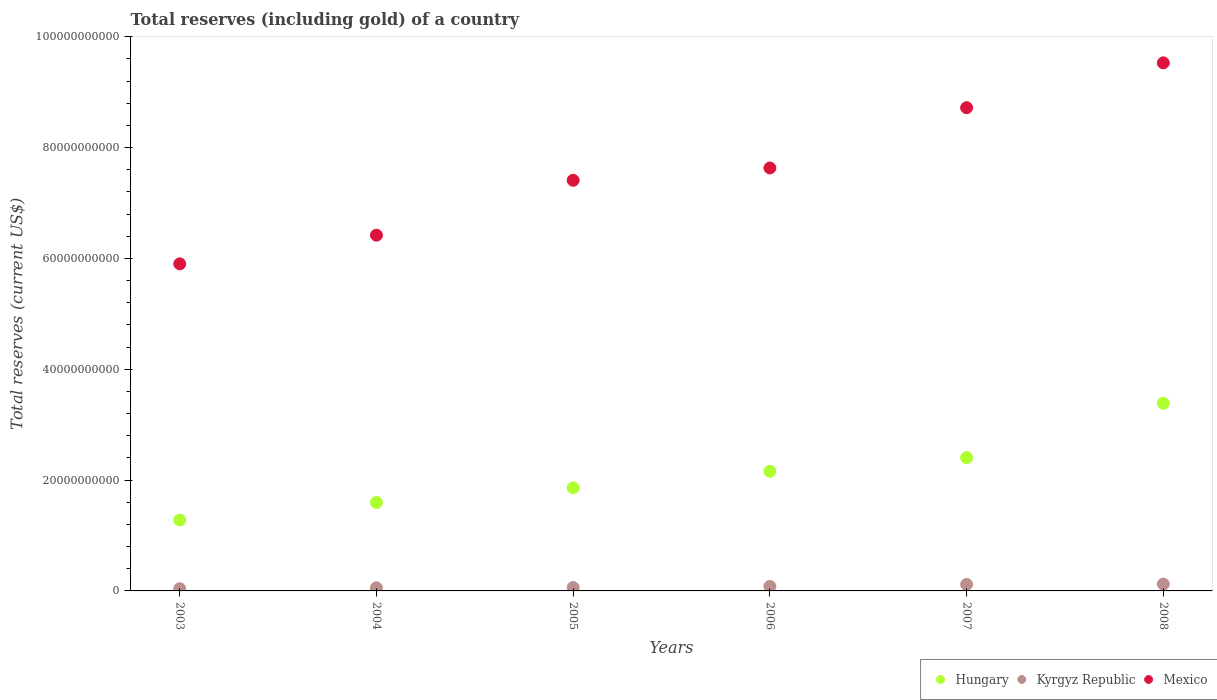What is the total reserves (including gold) in Mexico in 2007?
Provide a short and direct response. 8.72e+1. Across all years, what is the maximum total reserves (including gold) in Kyrgyz Republic?
Make the answer very short. 1.23e+09. Across all years, what is the minimum total reserves (including gold) in Kyrgyz Republic?
Offer a very short reply. 3.99e+08. What is the total total reserves (including gold) in Kyrgyz Republic in the graph?
Give a very brief answer. 4.79e+09. What is the difference between the total reserves (including gold) in Hungary in 2003 and that in 2004?
Ensure brevity in your answer.  -3.17e+09. What is the difference between the total reserves (including gold) in Mexico in 2004 and the total reserves (including gold) in Hungary in 2008?
Your answer should be very brief. 3.03e+1. What is the average total reserves (including gold) in Hungary per year?
Your answer should be compact. 2.11e+1. In the year 2005, what is the difference between the total reserves (including gold) in Kyrgyz Republic and total reserves (including gold) in Hungary?
Give a very brief answer. -1.80e+1. In how many years, is the total reserves (including gold) in Mexico greater than 48000000000 US$?
Your response must be concise. 6. What is the ratio of the total reserves (including gold) in Kyrgyz Republic in 2003 to that in 2006?
Give a very brief answer. 0.49. Is the difference between the total reserves (including gold) in Kyrgyz Republic in 2005 and 2008 greater than the difference between the total reserves (including gold) in Hungary in 2005 and 2008?
Your response must be concise. Yes. What is the difference between the highest and the second highest total reserves (including gold) in Mexico?
Your response must be concise. 8.09e+09. What is the difference between the highest and the lowest total reserves (including gold) in Kyrgyz Republic?
Your response must be concise. 8.26e+08. In how many years, is the total reserves (including gold) in Kyrgyz Republic greater than the average total reserves (including gold) in Kyrgyz Republic taken over all years?
Keep it short and to the point. 3. Is the total reserves (including gold) in Mexico strictly greater than the total reserves (including gold) in Kyrgyz Republic over the years?
Provide a short and direct response. Yes. What is the difference between two consecutive major ticks on the Y-axis?
Your answer should be very brief. 2.00e+1. Does the graph contain any zero values?
Your answer should be compact. No. Where does the legend appear in the graph?
Your answer should be very brief. Bottom right. What is the title of the graph?
Ensure brevity in your answer.  Total reserves (including gold) of a country. What is the label or title of the X-axis?
Your answer should be compact. Years. What is the label or title of the Y-axis?
Offer a terse response. Total reserves (current US$). What is the Total reserves (current US$) in Hungary in 2003?
Offer a terse response. 1.28e+1. What is the Total reserves (current US$) in Kyrgyz Republic in 2003?
Keep it short and to the point. 3.99e+08. What is the Total reserves (current US$) in Mexico in 2003?
Ensure brevity in your answer.  5.90e+1. What is the Total reserves (current US$) in Hungary in 2004?
Provide a succinct answer. 1.60e+1. What is the Total reserves (current US$) of Kyrgyz Republic in 2004?
Ensure brevity in your answer.  5.65e+08. What is the Total reserves (current US$) of Mexico in 2004?
Provide a succinct answer. 6.42e+1. What is the Total reserves (current US$) of Hungary in 2005?
Offer a terse response. 1.86e+1. What is the Total reserves (current US$) in Kyrgyz Republic in 2005?
Provide a succinct answer. 6.12e+08. What is the Total reserves (current US$) in Mexico in 2005?
Your answer should be very brief. 7.41e+1. What is the Total reserves (current US$) of Hungary in 2006?
Make the answer very short. 2.16e+1. What is the Total reserves (current US$) of Kyrgyz Republic in 2006?
Offer a very short reply. 8.17e+08. What is the Total reserves (current US$) of Mexico in 2006?
Give a very brief answer. 7.63e+1. What is the Total reserves (current US$) in Hungary in 2007?
Make the answer very short. 2.41e+1. What is the Total reserves (current US$) in Kyrgyz Republic in 2007?
Your answer should be very brief. 1.18e+09. What is the Total reserves (current US$) of Mexico in 2007?
Offer a very short reply. 8.72e+1. What is the Total reserves (current US$) in Hungary in 2008?
Provide a short and direct response. 3.39e+1. What is the Total reserves (current US$) in Kyrgyz Republic in 2008?
Your response must be concise. 1.23e+09. What is the Total reserves (current US$) of Mexico in 2008?
Ensure brevity in your answer.  9.53e+1. Across all years, what is the maximum Total reserves (current US$) in Hungary?
Your response must be concise. 3.39e+1. Across all years, what is the maximum Total reserves (current US$) of Kyrgyz Republic?
Your answer should be very brief. 1.23e+09. Across all years, what is the maximum Total reserves (current US$) of Mexico?
Offer a terse response. 9.53e+1. Across all years, what is the minimum Total reserves (current US$) in Hungary?
Give a very brief answer. 1.28e+1. Across all years, what is the minimum Total reserves (current US$) in Kyrgyz Republic?
Offer a terse response. 3.99e+08. Across all years, what is the minimum Total reserves (current US$) in Mexico?
Provide a succinct answer. 5.90e+1. What is the total Total reserves (current US$) of Hungary in the graph?
Make the answer very short. 1.27e+11. What is the total Total reserves (current US$) in Kyrgyz Republic in the graph?
Ensure brevity in your answer.  4.79e+09. What is the total Total reserves (current US$) of Mexico in the graph?
Make the answer very short. 4.56e+11. What is the difference between the Total reserves (current US$) of Hungary in 2003 and that in 2004?
Offer a very short reply. -3.17e+09. What is the difference between the Total reserves (current US$) of Kyrgyz Republic in 2003 and that in 2004?
Make the answer very short. -1.65e+08. What is the difference between the Total reserves (current US$) of Mexico in 2003 and that in 2004?
Offer a very short reply. -5.18e+09. What is the difference between the Total reserves (current US$) of Hungary in 2003 and that in 2005?
Your answer should be compact. -5.81e+09. What is the difference between the Total reserves (current US$) of Kyrgyz Republic in 2003 and that in 2005?
Give a very brief answer. -2.13e+08. What is the difference between the Total reserves (current US$) of Mexico in 2003 and that in 2005?
Your response must be concise. -1.51e+1. What is the difference between the Total reserves (current US$) in Hungary in 2003 and that in 2006?
Make the answer very short. -8.80e+09. What is the difference between the Total reserves (current US$) of Kyrgyz Republic in 2003 and that in 2006?
Offer a very short reply. -4.18e+08. What is the difference between the Total reserves (current US$) in Mexico in 2003 and that in 2006?
Make the answer very short. -1.73e+1. What is the difference between the Total reserves (current US$) of Hungary in 2003 and that in 2007?
Give a very brief answer. -1.13e+1. What is the difference between the Total reserves (current US$) of Kyrgyz Republic in 2003 and that in 2007?
Your response must be concise. -7.77e+08. What is the difference between the Total reserves (current US$) in Mexico in 2003 and that in 2007?
Your response must be concise. -2.82e+1. What is the difference between the Total reserves (current US$) of Hungary in 2003 and that in 2008?
Give a very brief answer. -2.11e+1. What is the difference between the Total reserves (current US$) in Kyrgyz Republic in 2003 and that in 2008?
Your answer should be very brief. -8.26e+08. What is the difference between the Total reserves (current US$) of Mexico in 2003 and that in 2008?
Your response must be concise. -3.63e+1. What is the difference between the Total reserves (current US$) in Hungary in 2004 and that in 2005?
Give a very brief answer. -2.64e+09. What is the difference between the Total reserves (current US$) in Kyrgyz Republic in 2004 and that in 2005?
Offer a very short reply. -4.78e+07. What is the difference between the Total reserves (current US$) in Mexico in 2004 and that in 2005?
Offer a very short reply. -9.91e+09. What is the difference between the Total reserves (current US$) in Hungary in 2004 and that in 2006?
Your answer should be very brief. -5.62e+09. What is the difference between the Total reserves (current US$) of Kyrgyz Republic in 2004 and that in 2006?
Keep it short and to the point. -2.53e+08. What is the difference between the Total reserves (current US$) of Mexico in 2004 and that in 2006?
Offer a very short reply. -1.21e+1. What is the difference between the Total reserves (current US$) of Hungary in 2004 and that in 2007?
Make the answer very short. -8.09e+09. What is the difference between the Total reserves (current US$) in Kyrgyz Republic in 2004 and that in 2007?
Offer a very short reply. -6.12e+08. What is the difference between the Total reserves (current US$) of Mexico in 2004 and that in 2007?
Ensure brevity in your answer.  -2.30e+1. What is the difference between the Total reserves (current US$) of Hungary in 2004 and that in 2008?
Offer a terse response. -1.79e+1. What is the difference between the Total reserves (current US$) in Kyrgyz Republic in 2004 and that in 2008?
Offer a very short reply. -6.61e+08. What is the difference between the Total reserves (current US$) in Mexico in 2004 and that in 2008?
Keep it short and to the point. -3.11e+1. What is the difference between the Total reserves (current US$) of Hungary in 2005 and that in 2006?
Offer a very short reply. -2.99e+09. What is the difference between the Total reserves (current US$) in Kyrgyz Republic in 2005 and that in 2006?
Provide a short and direct response. -2.05e+08. What is the difference between the Total reserves (current US$) of Mexico in 2005 and that in 2006?
Keep it short and to the point. -2.22e+09. What is the difference between the Total reserves (current US$) of Hungary in 2005 and that in 2007?
Offer a terse response. -5.45e+09. What is the difference between the Total reserves (current US$) in Kyrgyz Republic in 2005 and that in 2007?
Provide a succinct answer. -5.64e+08. What is the difference between the Total reserves (current US$) in Mexico in 2005 and that in 2007?
Make the answer very short. -1.31e+1. What is the difference between the Total reserves (current US$) in Hungary in 2005 and that in 2008?
Provide a succinct answer. -1.53e+1. What is the difference between the Total reserves (current US$) of Kyrgyz Republic in 2005 and that in 2008?
Provide a short and direct response. -6.13e+08. What is the difference between the Total reserves (current US$) of Mexico in 2005 and that in 2008?
Your answer should be very brief. -2.12e+1. What is the difference between the Total reserves (current US$) in Hungary in 2006 and that in 2007?
Your answer should be compact. -2.46e+09. What is the difference between the Total reserves (current US$) in Kyrgyz Republic in 2006 and that in 2007?
Offer a very short reply. -3.59e+08. What is the difference between the Total reserves (current US$) in Mexico in 2006 and that in 2007?
Give a very brief answer. -1.09e+1. What is the difference between the Total reserves (current US$) in Hungary in 2006 and that in 2008?
Ensure brevity in your answer.  -1.23e+1. What is the difference between the Total reserves (current US$) of Kyrgyz Republic in 2006 and that in 2008?
Ensure brevity in your answer.  -4.08e+08. What is the difference between the Total reserves (current US$) in Mexico in 2006 and that in 2008?
Your response must be concise. -1.90e+1. What is the difference between the Total reserves (current US$) in Hungary in 2007 and that in 2008?
Offer a terse response. -9.82e+09. What is the difference between the Total reserves (current US$) of Kyrgyz Republic in 2007 and that in 2008?
Offer a very short reply. -4.86e+07. What is the difference between the Total reserves (current US$) in Mexico in 2007 and that in 2008?
Your response must be concise. -8.09e+09. What is the difference between the Total reserves (current US$) of Hungary in 2003 and the Total reserves (current US$) of Kyrgyz Republic in 2004?
Keep it short and to the point. 1.22e+1. What is the difference between the Total reserves (current US$) of Hungary in 2003 and the Total reserves (current US$) of Mexico in 2004?
Provide a short and direct response. -5.14e+1. What is the difference between the Total reserves (current US$) in Kyrgyz Republic in 2003 and the Total reserves (current US$) in Mexico in 2004?
Provide a short and direct response. -6.38e+1. What is the difference between the Total reserves (current US$) in Hungary in 2003 and the Total reserves (current US$) in Kyrgyz Republic in 2005?
Offer a very short reply. 1.22e+1. What is the difference between the Total reserves (current US$) in Hungary in 2003 and the Total reserves (current US$) in Mexico in 2005?
Offer a terse response. -6.13e+1. What is the difference between the Total reserves (current US$) of Kyrgyz Republic in 2003 and the Total reserves (current US$) of Mexico in 2005?
Provide a short and direct response. -7.37e+1. What is the difference between the Total reserves (current US$) of Hungary in 2003 and the Total reserves (current US$) of Kyrgyz Republic in 2006?
Provide a succinct answer. 1.20e+1. What is the difference between the Total reserves (current US$) of Hungary in 2003 and the Total reserves (current US$) of Mexico in 2006?
Offer a very short reply. -6.35e+1. What is the difference between the Total reserves (current US$) of Kyrgyz Republic in 2003 and the Total reserves (current US$) of Mexico in 2006?
Provide a succinct answer. -7.59e+1. What is the difference between the Total reserves (current US$) of Hungary in 2003 and the Total reserves (current US$) of Kyrgyz Republic in 2007?
Provide a short and direct response. 1.16e+1. What is the difference between the Total reserves (current US$) of Hungary in 2003 and the Total reserves (current US$) of Mexico in 2007?
Your response must be concise. -7.44e+1. What is the difference between the Total reserves (current US$) in Kyrgyz Republic in 2003 and the Total reserves (current US$) in Mexico in 2007?
Provide a short and direct response. -8.68e+1. What is the difference between the Total reserves (current US$) in Hungary in 2003 and the Total reserves (current US$) in Kyrgyz Republic in 2008?
Your answer should be compact. 1.16e+1. What is the difference between the Total reserves (current US$) of Hungary in 2003 and the Total reserves (current US$) of Mexico in 2008?
Keep it short and to the point. -8.25e+1. What is the difference between the Total reserves (current US$) in Kyrgyz Republic in 2003 and the Total reserves (current US$) in Mexico in 2008?
Ensure brevity in your answer.  -9.49e+1. What is the difference between the Total reserves (current US$) of Hungary in 2004 and the Total reserves (current US$) of Kyrgyz Republic in 2005?
Your answer should be very brief. 1.54e+1. What is the difference between the Total reserves (current US$) in Hungary in 2004 and the Total reserves (current US$) in Mexico in 2005?
Offer a terse response. -5.81e+1. What is the difference between the Total reserves (current US$) of Kyrgyz Republic in 2004 and the Total reserves (current US$) of Mexico in 2005?
Ensure brevity in your answer.  -7.35e+1. What is the difference between the Total reserves (current US$) in Hungary in 2004 and the Total reserves (current US$) in Kyrgyz Republic in 2006?
Provide a short and direct response. 1.51e+1. What is the difference between the Total reserves (current US$) of Hungary in 2004 and the Total reserves (current US$) of Mexico in 2006?
Give a very brief answer. -6.04e+1. What is the difference between the Total reserves (current US$) in Kyrgyz Republic in 2004 and the Total reserves (current US$) in Mexico in 2006?
Provide a short and direct response. -7.58e+1. What is the difference between the Total reserves (current US$) in Hungary in 2004 and the Total reserves (current US$) in Kyrgyz Republic in 2007?
Make the answer very short. 1.48e+1. What is the difference between the Total reserves (current US$) in Hungary in 2004 and the Total reserves (current US$) in Mexico in 2007?
Provide a short and direct response. -7.12e+1. What is the difference between the Total reserves (current US$) in Kyrgyz Republic in 2004 and the Total reserves (current US$) in Mexico in 2007?
Keep it short and to the point. -8.66e+1. What is the difference between the Total reserves (current US$) of Hungary in 2004 and the Total reserves (current US$) of Kyrgyz Republic in 2008?
Make the answer very short. 1.47e+1. What is the difference between the Total reserves (current US$) of Hungary in 2004 and the Total reserves (current US$) of Mexico in 2008?
Ensure brevity in your answer.  -7.93e+1. What is the difference between the Total reserves (current US$) of Kyrgyz Republic in 2004 and the Total reserves (current US$) of Mexico in 2008?
Provide a succinct answer. -9.47e+1. What is the difference between the Total reserves (current US$) of Hungary in 2005 and the Total reserves (current US$) of Kyrgyz Republic in 2006?
Your answer should be compact. 1.78e+1. What is the difference between the Total reserves (current US$) in Hungary in 2005 and the Total reserves (current US$) in Mexico in 2006?
Provide a succinct answer. -5.77e+1. What is the difference between the Total reserves (current US$) in Kyrgyz Republic in 2005 and the Total reserves (current US$) in Mexico in 2006?
Keep it short and to the point. -7.57e+1. What is the difference between the Total reserves (current US$) in Hungary in 2005 and the Total reserves (current US$) in Kyrgyz Republic in 2007?
Offer a terse response. 1.74e+1. What is the difference between the Total reserves (current US$) of Hungary in 2005 and the Total reserves (current US$) of Mexico in 2007?
Offer a very short reply. -6.86e+1. What is the difference between the Total reserves (current US$) of Kyrgyz Republic in 2005 and the Total reserves (current US$) of Mexico in 2007?
Make the answer very short. -8.66e+1. What is the difference between the Total reserves (current US$) of Hungary in 2005 and the Total reserves (current US$) of Kyrgyz Republic in 2008?
Offer a terse response. 1.74e+1. What is the difference between the Total reserves (current US$) in Hungary in 2005 and the Total reserves (current US$) in Mexico in 2008?
Your answer should be compact. -7.67e+1. What is the difference between the Total reserves (current US$) of Kyrgyz Republic in 2005 and the Total reserves (current US$) of Mexico in 2008?
Your response must be concise. -9.47e+1. What is the difference between the Total reserves (current US$) of Hungary in 2006 and the Total reserves (current US$) of Kyrgyz Republic in 2007?
Your answer should be compact. 2.04e+1. What is the difference between the Total reserves (current US$) in Hungary in 2006 and the Total reserves (current US$) in Mexico in 2007?
Your response must be concise. -6.56e+1. What is the difference between the Total reserves (current US$) in Kyrgyz Republic in 2006 and the Total reserves (current US$) in Mexico in 2007?
Your answer should be very brief. -8.64e+1. What is the difference between the Total reserves (current US$) in Hungary in 2006 and the Total reserves (current US$) in Kyrgyz Republic in 2008?
Keep it short and to the point. 2.04e+1. What is the difference between the Total reserves (current US$) of Hungary in 2006 and the Total reserves (current US$) of Mexico in 2008?
Keep it short and to the point. -7.37e+1. What is the difference between the Total reserves (current US$) of Kyrgyz Republic in 2006 and the Total reserves (current US$) of Mexico in 2008?
Your answer should be compact. -9.45e+1. What is the difference between the Total reserves (current US$) in Hungary in 2007 and the Total reserves (current US$) in Kyrgyz Republic in 2008?
Make the answer very short. 2.28e+1. What is the difference between the Total reserves (current US$) of Hungary in 2007 and the Total reserves (current US$) of Mexico in 2008?
Keep it short and to the point. -7.12e+1. What is the difference between the Total reserves (current US$) of Kyrgyz Republic in 2007 and the Total reserves (current US$) of Mexico in 2008?
Your answer should be very brief. -9.41e+1. What is the average Total reserves (current US$) in Hungary per year?
Ensure brevity in your answer.  2.11e+1. What is the average Total reserves (current US$) in Kyrgyz Republic per year?
Offer a very short reply. 7.99e+08. What is the average Total reserves (current US$) in Mexico per year?
Give a very brief answer. 7.60e+1. In the year 2003, what is the difference between the Total reserves (current US$) in Hungary and Total reserves (current US$) in Kyrgyz Republic?
Give a very brief answer. 1.24e+1. In the year 2003, what is the difference between the Total reserves (current US$) in Hungary and Total reserves (current US$) in Mexico?
Offer a very short reply. -4.62e+1. In the year 2003, what is the difference between the Total reserves (current US$) in Kyrgyz Republic and Total reserves (current US$) in Mexico?
Provide a short and direct response. -5.86e+1. In the year 2004, what is the difference between the Total reserves (current US$) of Hungary and Total reserves (current US$) of Kyrgyz Republic?
Ensure brevity in your answer.  1.54e+1. In the year 2004, what is the difference between the Total reserves (current US$) in Hungary and Total reserves (current US$) in Mexico?
Make the answer very short. -4.82e+1. In the year 2004, what is the difference between the Total reserves (current US$) of Kyrgyz Republic and Total reserves (current US$) of Mexico?
Give a very brief answer. -6.36e+1. In the year 2005, what is the difference between the Total reserves (current US$) of Hungary and Total reserves (current US$) of Kyrgyz Republic?
Ensure brevity in your answer.  1.80e+1. In the year 2005, what is the difference between the Total reserves (current US$) of Hungary and Total reserves (current US$) of Mexico?
Your answer should be very brief. -5.55e+1. In the year 2005, what is the difference between the Total reserves (current US$) in Kyrgyz Republic and Total reserves (current US$) in Mexico?
Offer a very short reply. -7.35e+1. In the year 2006, what is the difference between the Total reserves (current US$) in Hungary and Total reserves (current US$) in Kyrgyz Republic?
Your response must be concise. 2.08e+1. In the year 2006, what is the difference between the Total reserves (current US$) in Hungary and Total reserves (current US$) in Mexico?
Your answer should be compact. -5.47e+1. In the year 2006, what is the difference between the Total reserves (current US$) of Kyrgyz Republic and Total reserves (current US$) of Mexico?
Ensure brevity in your answer.  -7.55e+1. In the year 2007, what is the difference between the Total reserves (current US$) in Hungary and Total reserves (current US$) in Kyrgyz Republic?
Your answer should be very brief. 2.29e+1. In the year 2007, what is the difference between the Total reserves (current US$) of Hungary and Total reserves (current US$) of Mexico?
Your response must be concise. -6.32e+1. In the year 2007, what is the difference between the Total reserves (current US$) of Kyrgyz Republic and Total reserves (current US$) of Mexico?
Make the answer very short. -8.60e+1. In the year 2008, what is the difference between the Total reserves (current US$) of Hungary and Total reserves (current US$) of Kyrgyz Republic?
Give a very brief answer. 3.26e+1. In the year 2008, what is the difference between the Total reserves (current US$) in Hungary and Total reserves (current US$) in Mexico?
Offer a very short reply. -6.14e+1. In the year 2008, what is the difference between the Total reserves (current US$) of Kyrgyz Republic and Total reserves (current US$) of Mexico?
Keep it short and to the point. -9.41e+1. What is the ratio of the Total reserves (current US$) in Hungary in 2003 to that in 2004?
Your answer should be very brief. 0.8. What is the ratio of the Total reserves (current US$) in Kyrgyz Republic in 2003 to that in 2004?
Give a very brief answer. 0.71. What is the ratio of the Total reserves (current US$) of Mexico in 2003 to that in 2004?
Your answer should be very brief. 0.92. What is the ratio of the Total reserves (current US$) of Hungary in 2003 to that in 2005?
Offer a very short reply. 0.69. What is the ratio of the Total reserves (current US$) in Kyrgyz Republic in 2003 to that in 2005?
Provide a short and direct response. 0.65. What is the ratio of the Total reserves (current US$) in Mexico in 2003 to that in 2005?
Keep it short and to the point. 0.8. What is the ratio of the Total reserves (current US$) in Hungary in 2003 to that in 2006?
Your answer should be very brief. 0.59. What is the ratio of the Total reserves (current US$) of Kyrgyz Republic in 2003 to that in 2006?
Ensure brevity in your answer.  0.49. What is the ratio of the Total reserves (current US$) of Mexico in 2003 to that in 2006?
Make the answer very short. 0.77. What is the ratio of the Total reserves (current US$) of Hungary in 2003 to that in 2007?
Keep it short and to the point. 0.53. What is the ratio of the Total reserves (current US$) in Kyrgyz Republic in 2003 to that in 2007?
Your response must be concise. 0.34. What is the ratio of the Total reserves (current US$) of Mexico in 2003 to that in 2007?
Your response must be concise. 0.68. What is the ratio of the Total reserves (current US$) of Hungary in 2003 to that in 2008?
Offer a very short reply. 0.38. What is the ratio of the Total reserves (current US$) in Kyrgyz Republic in 2003 to that in 2008?
Provide a succinct answer. 0.33. What is the ratio of the Total reserves (current US$) in Mexico in 2003 to that in 2008?
Give a very brief answer. 0.62. What is the ratio of the Total reserves (current US$) of Hungary in 2004 to that in 2005?
Provide a succinct answer. 0.86. What is the ratio of the Total reserves (current US$) in Kyrgyz Republic in 2004 to that in 2005?
Ensure brevity in your answer.  0.92. What is the ratio of the Total reserves (current US$) in Mexico in 2004 to that in 2005?
Make the answer very short. 0.87. What is the ratio of the Total reserves (current US$) in Hungary in 2004 to that in 2006?
Your answer should be compact. 0.74. What is the ratio of the Total reserves (current US$) in Kyrgyz Republic in 2004 to that in 2006?
Keep it short and to the point. 0.69. What is the ratio of the Total reserves (current US$) in Mexico in 2004 to that in 2006?
Offer a very short reply. 0.84. What is the ratio of the Total reserves (current US$) in Hungary in 2004 to that in 2007?
Keep it short and to the point. 0.66. What is the ratio of the Total reserves (current US$) in Kyrgyz Republic in 2004 to that in 2007?
Keep it short and to the point. 0.48. What is the ratio of the Total reserves (current US$) in Mexico in 2004 to that in 2007?
Provide a succinct answer. 0.74. What is the ratio of the Total reserves (current US$) in Hungary in 2004 to that in 2008?
Provide a short and direct response. 0.47. What is the ratio of the Total reserves (current US$) of Kyrgyz Republic in 2004 to that in 2008?
Give a very brief answer. 0.46. What is the ratio of the Total reserves (current US$) of Mexico in 2004 to that in 2008?
Offer a very short reply. 0.67. What is the ratio of the Total reserves (current US$) of Hungary in 2005 to that in 2006?
Offer a terse response. 0.86. What is the ratio of the Total reserves (current US$) of Kyrgyz Republic in 2005 to that in 2006?
Your answer should be very brief. 0.75. What is the ratio of the Total reserves (current US$) of Mexico in 2005 to that in 2006?
Keep it short and to the point. 0.97. What is the ratio of the Total reserves (current US$) of Hungary in 2005 to that in 2007?
Provide a short and direct response. 0.77. What is the ratio of the Total reserves (current US$) of Kyrgyz Republic in 2005 to that in 2007?
Ensure brevity in your answer.  0.52. What is the ratio of the Total reserves (current US$) in Mexico in 2005 to that in 2007?
Provide a succinct answer. 0.85. What is the ratio of the Total reserves (current US$) in Hungary in 2005 to that in 2008?
Offer a very short reply. 0.55. What is the ratio of the Total reserves (current US$) in Kyrgyz Republic in 2005 to that in 2008?
Provide a short and direct response. 0.5. What is the ratio of the Total reserves (current US$) in Mexico in 2005 to that in 2008?
Your response must be concise. 0.78. What is the ratio of the Total reserves (current US$) in Hungary in 2006 to that in 2007?
Your response must be concise. 0.9. What is the ratio of the Total reserves (current US$) of Kyrgyz Republic in 2006 to that in 2007?
Keep it short and to the point. 0.69. What is the ratio of the Total reserves (current US$) of Mexico in 2006 to that in 2007?
Keep it short and to the point. 0.88. What is the ratio of the Total reserves (current US$) of Hungary in 2006 to that in 2008?
Provide a short and direct response. 0.64. What is the ratio of the Total reserves (current US$) of Kyrgyz Republic in 2006 to that in 2008?
Your answer should be compact. 0.67. What is the ratio of the Total reserves (current US$) in Mexico in 2006 to that in 2008?
Offer a very short reply. 0.8. What is the ratio of the Total reserves (current US$) of Hungary in 2007 to that in 2008?
Offer a terse response. 0.71. What is the ratio of the Total reserves (current US$) of Kyrgyz Republic in 2007 to that in 2008?
Give a very brief answer. 0.96. What is the ratio of the Total reserves (current US$) of Mexico in 2007 to that in 2008?
Give a very brief answer. 0.92. What is the difference between the highest and the second highest Total reserves (current US$) of Hungary?
Provide a short and direct response. 9.82e+09. What is the difference between the highest and the second highest Total reserves (current US$) of Kyrgyz Republic?
Ensure brevity in your answer.  4.86e+07. What is the difference between the highest and the second highest Total reserves (current US$) in Mexico?
Your response must be concise. 8.09e+09. What is the difference between the highest and the lowest Total reserves (current US$) of Hungary?
Offer a very short reply. 2.11e+1. What is the difference between the highest and the lowest Total reserves (current US$) of Kyrgyz Republic?
Provide a succinct answer. 8.26e+08. What is the difference between the highest and the lowest Total reserves (current US$) of Mexico?
Provide a short and direct response. 3.63e+1. 